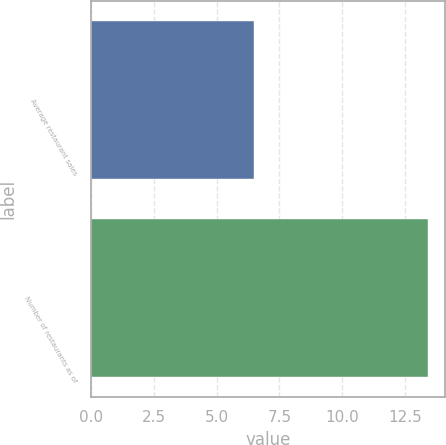Convert chart to OTSL. <chart><loc_0><loc_0><loc_500><loc_500><bar_chart><fcel>Average restaurant sales<fcel>Number of restaurants as of<nl><fcel>6.5<fcel>13.4<nl></chart> 